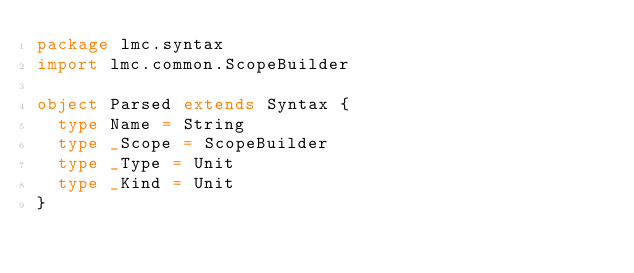Convert code to text. <code><loc_0><loc_0><loc_500><loc_500><_Scala_>package lmc.syntax
import lmc.common.ScopeBuilder

object Parsed extends Syntax {
  type Name = String
  type _Scope = ScopeBuilder
  type _Type = Unit
  type _Kind = Unit
}
</code> 